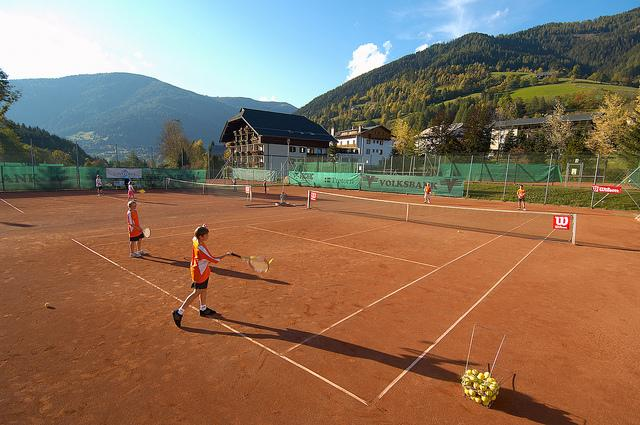What event is being carried out? Please explain your reasoning. tennis training. There are no spectators, and they are all wearing the same uniform, so it is assumed that this is a practice session. the bright yellow balls indicates that the sport is tennis. 